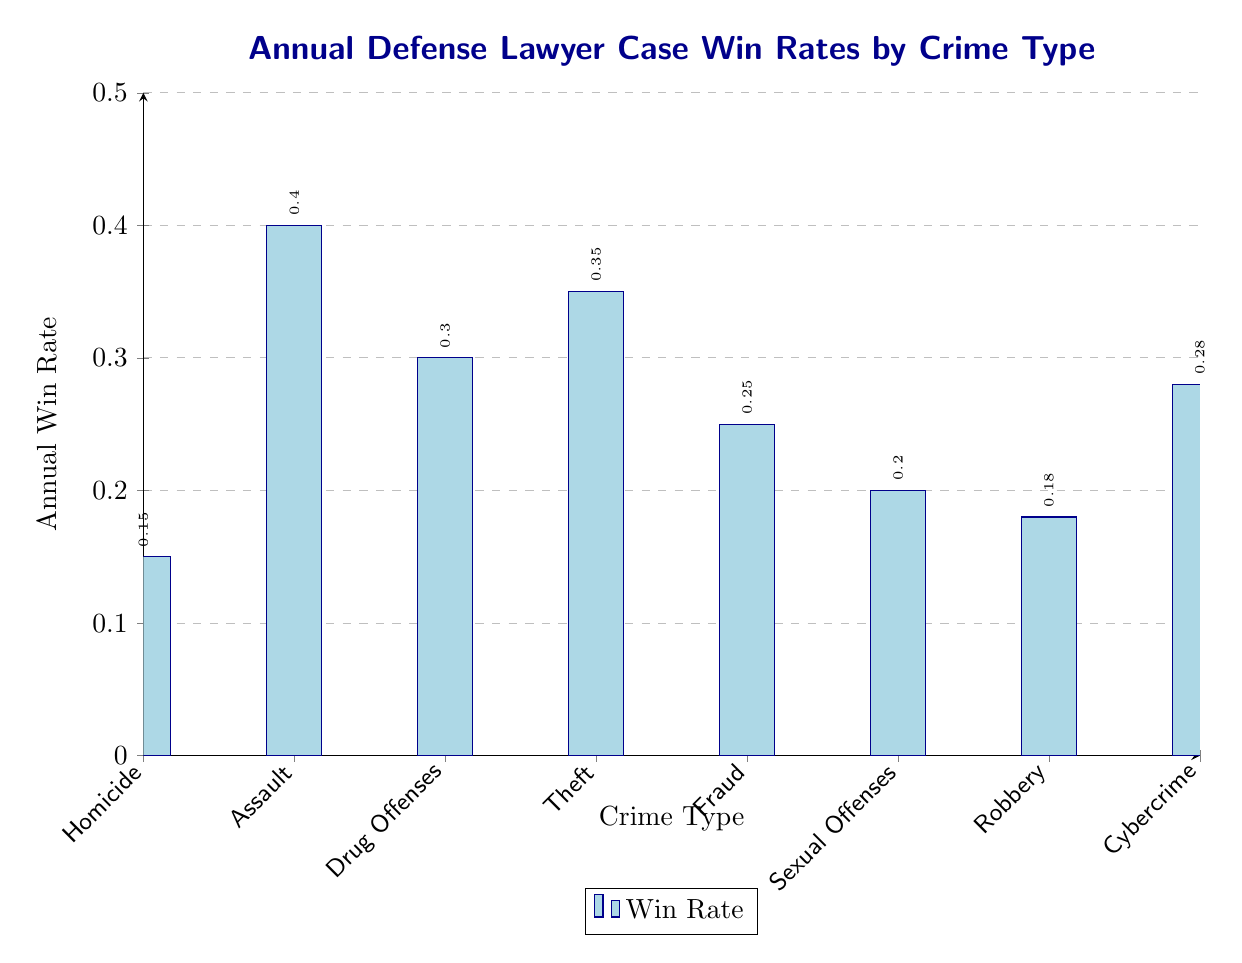What is the annual win rate for Assault cases? In the table, the win rate for Assault is directly provided, which is 0.40.
Answer: 0.40 Which crime type has the lowest annual win rate? Upon examining the table, Homicide has the lowest annual win rate of 0.15 compared to other crime types listed.
Answer: Homicide What is the average annual win rate for Drug Offenses and Cybercrime? The annual win rate for Drug Offenses is 0.30, and for Cybercrime it is 0.28. The average is calculated as (0.30 + 0.28) / 2 = 0.29.
Answer: 0.29 Is the win rate for Theft greater than or equal to the win rate for Fraud? The win rate for Theft is 0.35 and for Fraud it is 0.25. Since 0.35 is greater than 0.25, the statement is true.
Answer: Yes How many crime types have a win rate greater than 0.25? By analyzing the table, the crime types with win rates greater than 0.25 are Assault (0.40), Theft (0.35), Drug Offenses (0.30), and Cybercrime (0.28), totaling four crime types.
Answer: 4 What is the difference in win rates between Sexual Offenses and Robbery? The win rate for Sexual Offenses is 0.20, and for Robbery, it is 0.18. The difference is computed as 0.20 - 0.18 = 0.02.
Answer: 0.02 Which crime type has a win rate that is closest to the overall average win rate of the listed cases? The annual win rates sum to 2.10 for the eight crimes, making the average win rate 2.10 / 8 = 0.2625. The win rates closest to this average are Drug Offenses (0.30) and Cybercrime (0.28). Drug Offenses is slightly higher, while Cybercrime is slightly lower, but both are within a 0.0375 range.
Answer: Drug Offenses and Cybercrime Are the win rates for Sexual Offenses and Cybercrime both above 0.25? Sexual Offenses has a win rate of 0.20 and Cybercrime has a win rate of 0.28. Since only Cybercrime exceeds 0.25 and Sexual Offenses does not, the statement is false.
Answer: No 